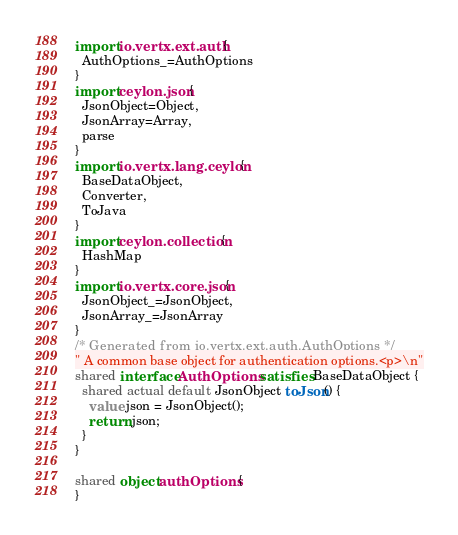Convert code to text. <code><loc_0><loc_0><loc_500><loc_500><_Ceylon_>import io.vertx.ext.auth {
  AuthOptions_=AuthOptions
}
import ceylon.json {
  JsonObject=Object,
  JsonArray=Array,
  parse
}
import io.vertx.lang.ceylon {
  BaseDataObject,
  Converter,
  ToJava
}
import ceylon.collection {
  HashMap
}
import io.vertx.core.json {
  JsonObject_=JsonObject,
  JsonArray_=JsonArray
}
/* Generated from io.vertx.ext.auth.AuthOptions */
" A common base object for authentication options.<p>\n"
shared interface AuthOptions satisfies BaseDataObject {
  shared actual default JsonObject toJson() {
    value json = JsonObject();
    return json;
  }
}

shared object authOptions {
}
</code> 